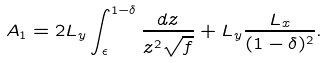<formula> <loc_0><loc_0><loc_500><loc_500>A _ { 1 } = 2 L _ { y } \int _ { \epsilon } ^ { 1 - \delta } \frac { d z } { z ^ { 2 } \sqrt { f } } + L _ { y } \frac { L _ { x } } { ( 1 - \delta ) ^ { 2 } } .</formula> 